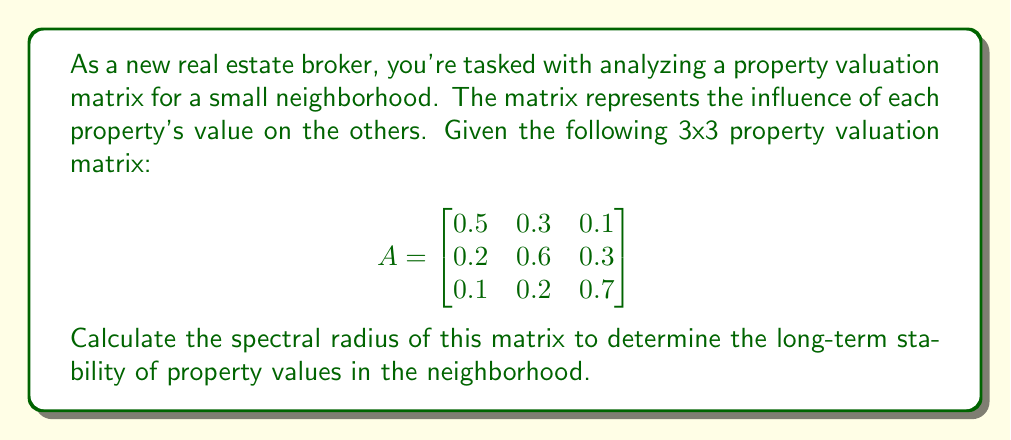Help me with this question. To calculate the spectral radius of matrix A, we need to follow these steps:

1. Find the characteristic polynomial of A:
   $det(A - \lambda I) = 0$
   
   $$\begin{vmatrix}
   0.5-\lambda & 0.3 & 0.1 \\
   0.2 & 0.6-\lambda & 0.3 \\
   0.1 & 0.2 & 0.7-\lambda
   \end{vmatrix} = 0$$

2. Expand the determinant:
   $(0.5-\lambda)[(0.6-\lambda)(0.7-\lambda)-0.06] - 0.3[0.2(0.7-\lambda)-0.03] + 0.1[0.2(0.6-\lambda)-0.06] = 0$

3. Simplify:
   $-\lambda^3 + 1.8\lambda^2 - 0.98\lambda + 0.162 = 0$

4. Solve this cubic equation to find the eigenvalues. We can use the cubic formula or numerical methods. The eigenvalues are approximately:
   $\lambda_1 \approx 0.9742$
   $\lambda_2 \approx 0.4687$
   $\lambda_3 \approx 0.3571$

5. The spectral radius is the largest absolute value of the eigenvalues:
   $\rho(A) = \max(|\lambda_1|, |\lambda_2|, |\lambda_3|) = |\lambda_1| \approx 0.9742$
Answer: $\rho(A) \approx 0.9742$ 